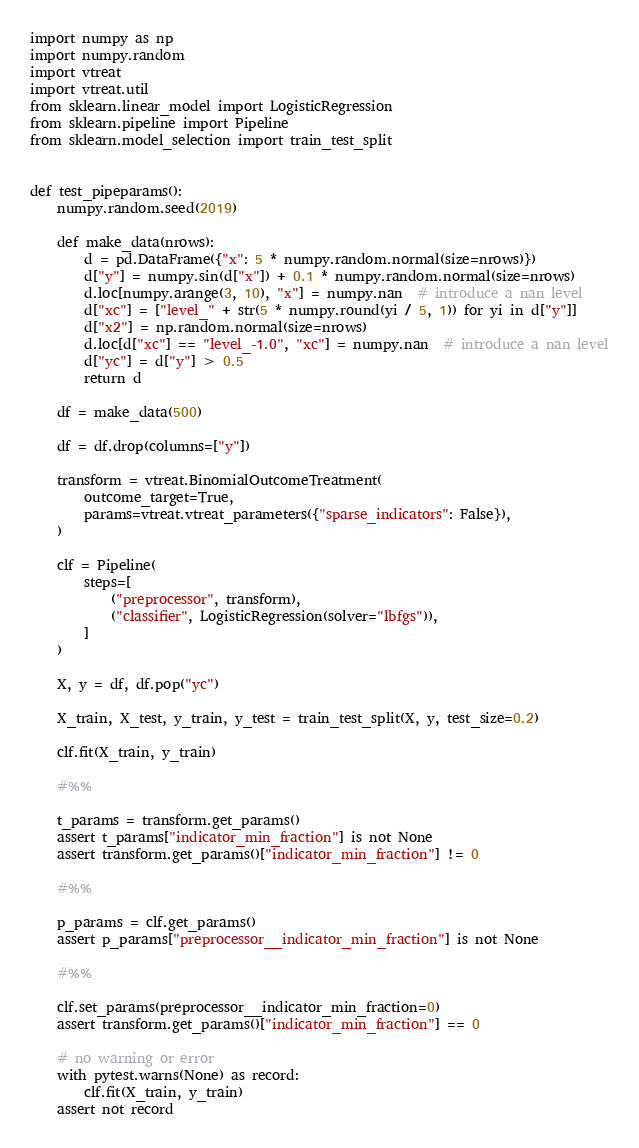<code> <loc_0><loc_0><loc_500><loc_500><_Python_>import numpy as np
import numpy.random
import vtreat
import vtreat.util
from sklearn.linear_model import LogisticRegression
from sklearn.pipeline import Pipeline
from sklearn.model_selection import train_test_split


def test_pipeparams():
    numpy.random.seed(2019)

    def make_data(nrows):
        d = pd.DataFrame({"x": 5 * numpy.random.normal(size=nrows)})
        d["y"] = numpy.sin(d["x"]) + 0.1 * numpy.random.normal(size=nrows)
        d.loc[numpy.arange(3, 10), "x"] = numpy.nan  # introduce a nan level
        d["xc"] = ["level_" + str(5 * numpy.round(yi / 5, 1)) for yi in d["y"]]
        d["x2"] = np.random.normal(size=nrows)
        d.loc[d["xc"] == "level_-1.0", "xc"] = numpy.nan  # introduce a nan level
        d["yc"] = d["y"] > 0.5
        return d

    df = make_data(500)

    df = df.drop(columns=["y"])

    transform = vtreat.BinomialOutcomeTreatment(
        outcome_target=True,
        params=vtreat.vtreat_parameters({"sparse_indicators": False}),
    )

    clf = Pipeline(
        steps=[
            ("preprocessor", transform),
            ("classifier", LogisticRegression(solver="lbfgs")),
        ]
    )

    X, y = df, df.pop("yc")

    X_train, X_test, y_train, y_test = train_test_split(X, y, test_size=0.2)

    clf.fit(X_train, y_train)

    #%%

    t_params = transform.get_params()
    assert t_params["indicator_min_fraction"] is not None
    assert transform.get_params()["indicator_min_fraction"] != 0

    #%%

    p_params = clf.get_params()
    assert p_params["preprocessor__indicator_min_fraction"] is not None

    #%%

    clf.set_params(preprocessor__indicator_min_fraction=0)
    assert transform.get_params()["indicator_min_fraction"] == 0

    # no warning or error
    with pytest.warns(None) as record:
        clf.fit(X_train, y_train)
    assert not record
</code> 